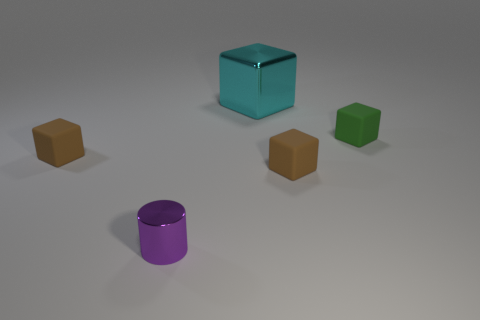Add 4 tiny red rubber spheres. How many objects exist? 9 Subtract all cylinders. How many objects are left? 4 Subtract all purple metal things. Subtract all large metallic cubes. How many objects are left? 3 Add 3 purple objects. How many purple objects are left? 4 Add 5 purple metallic cylinders. How many purple metallic cylinders exist? 6 Subtract 0 yellow cylinders. How many objects are left? 5 